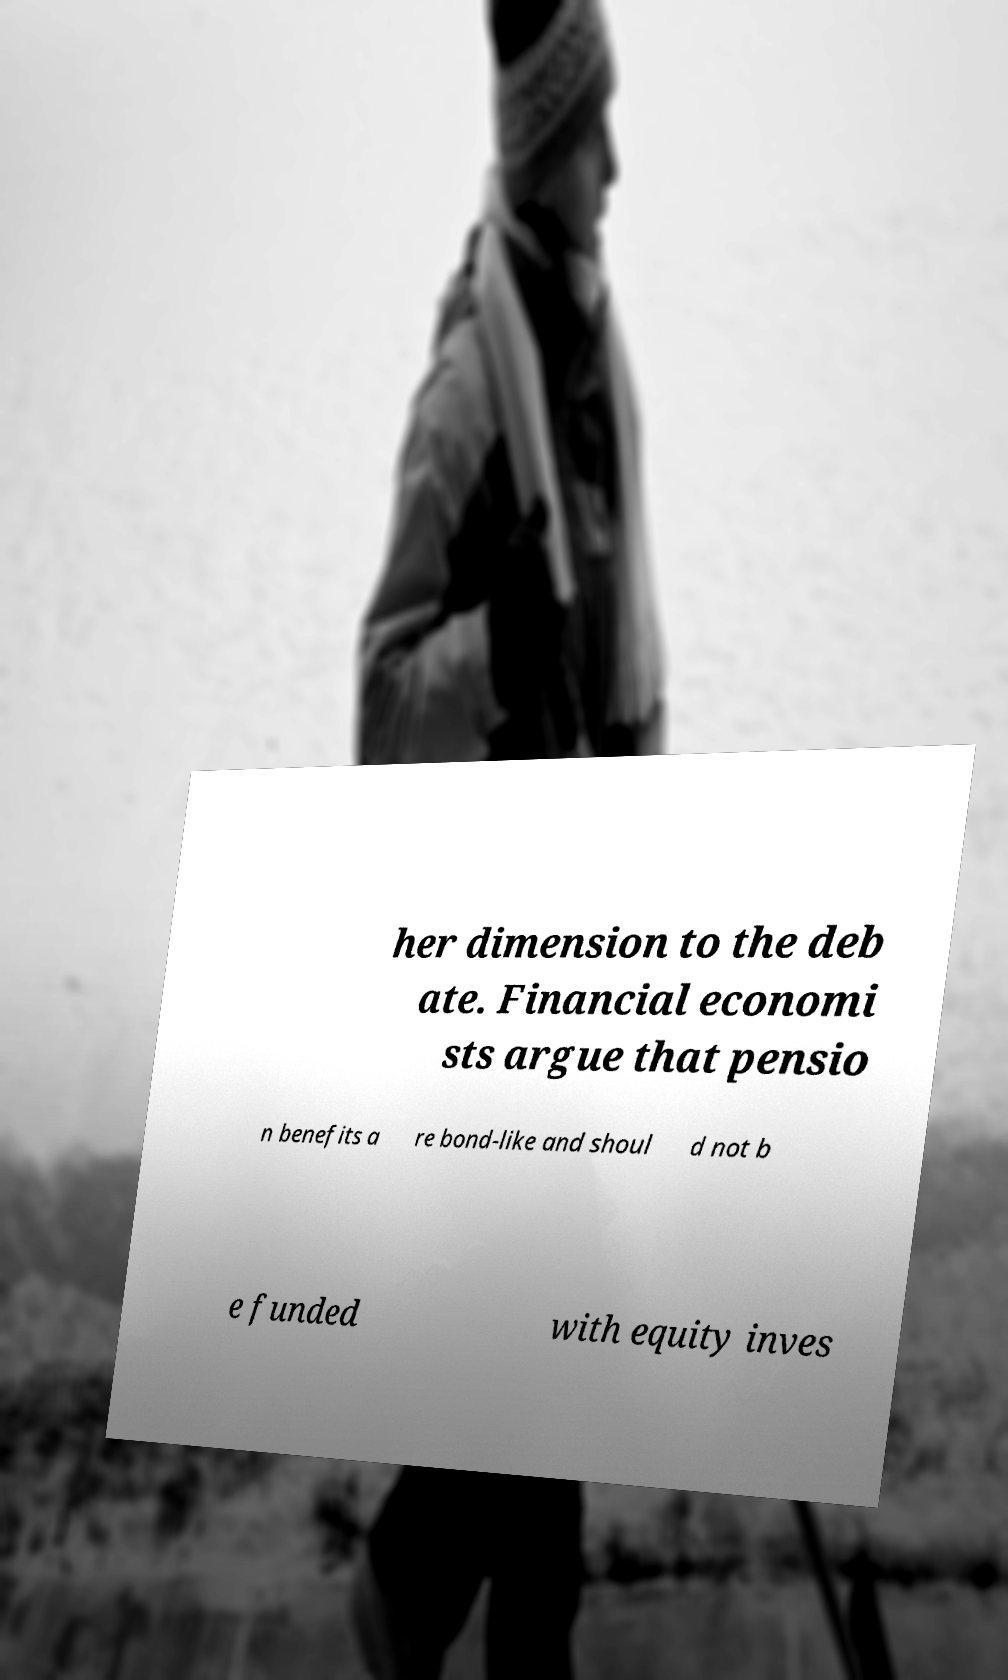Can you accurately transcribe the text from the provided image for me? her dimension to the deb ate. Financial economi sts argue that pensio n benefits a re bond-like and shoul d not b e funded with equity inves 